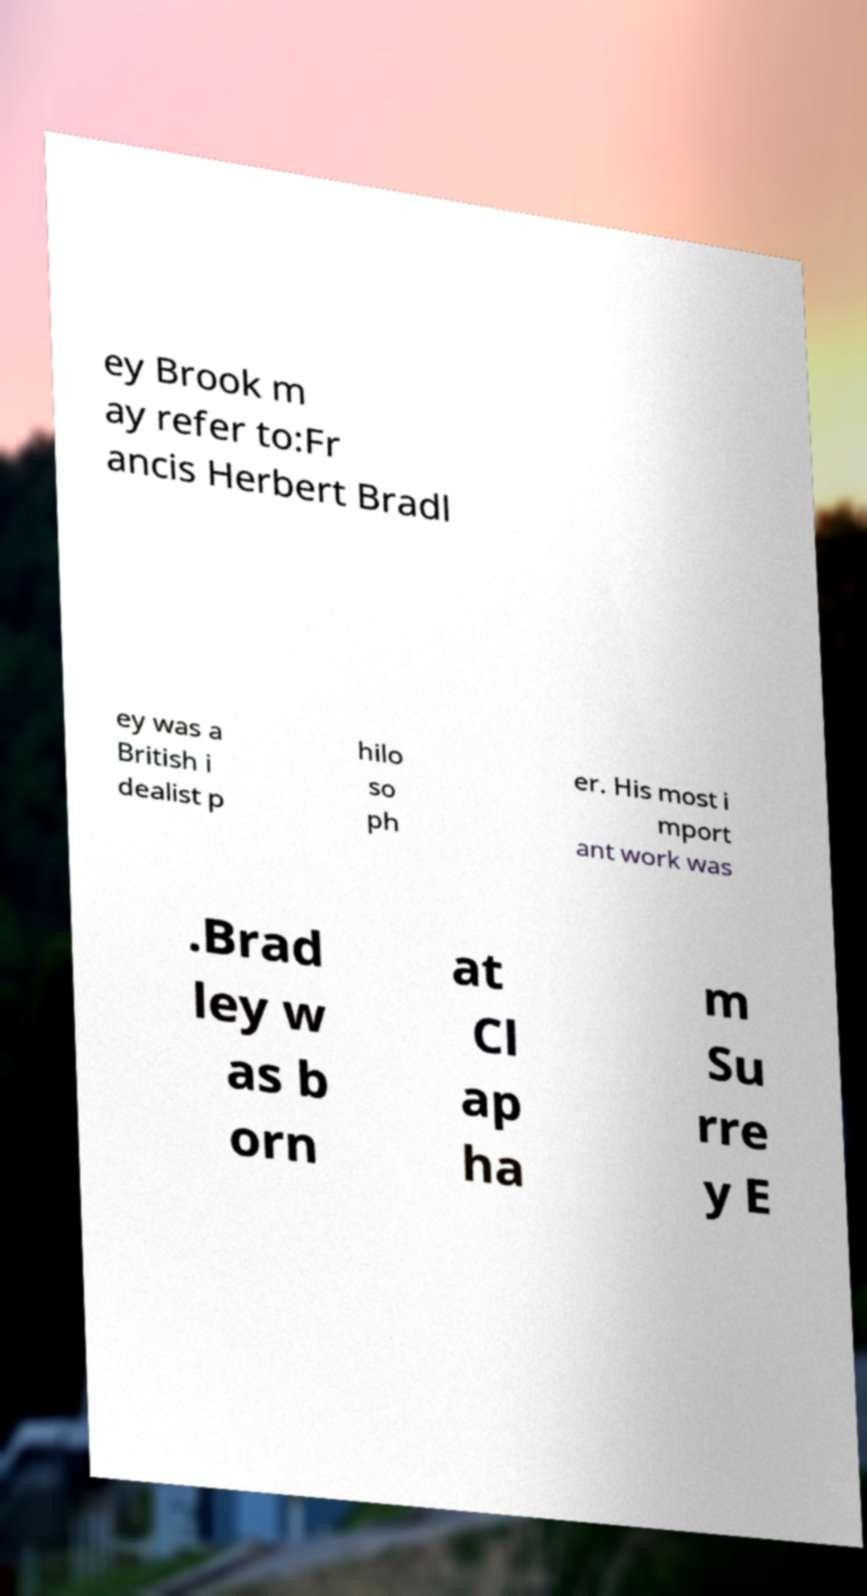Please read and relay the text visible in this image. What does it say? ey Brook m ay refer to:Fr ancis Herbert Bradl ey was a British i dealist p hilo so ph er. His most i mport ant work was .Brad ley w as b orn at Cl ap ha m Su rre y E 